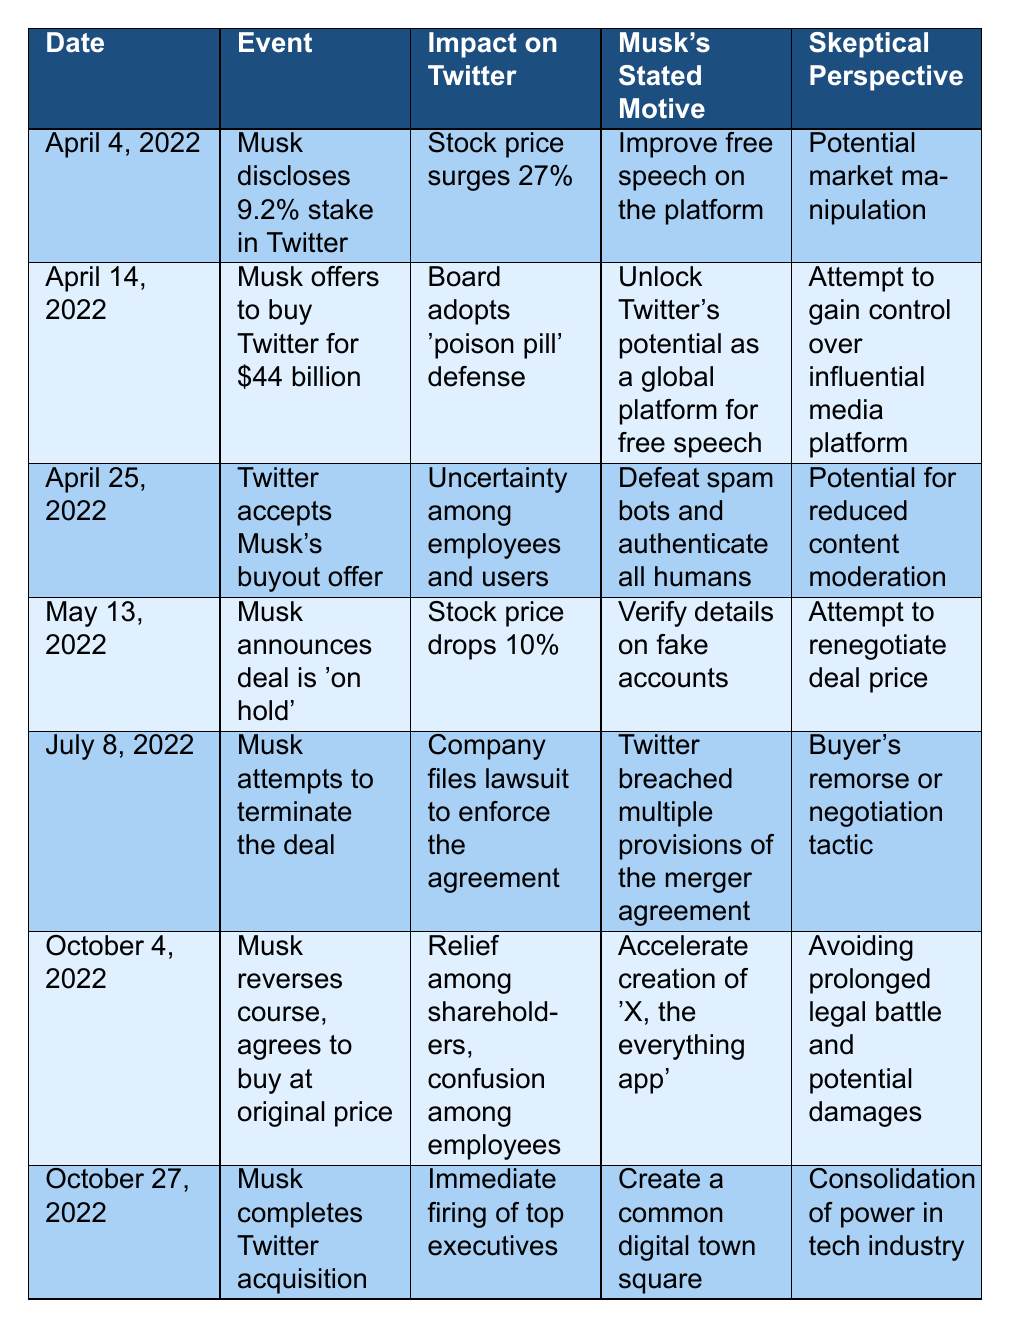What event happened on April 14, 2022? The table indicates that on April 14, 2022, Musk offered to buy Twitter for $44 billion.
Answer: Musk offers to buy Twitter for $44 billion What was the stock price change after Musk disclosed his stake on April 4, 2022? The table states that the stock price surged 27% after Musk disclosed his 9.2% stake in Twitter.
Answer: Stock price surged 27% Did Musk's motive change when he announced the deal was 'on hold' on May 13, 2022? Yes, Musk's stated motive changed to verifying details on fake accounts, which was different from his initial motivations concerning free speech.
Answer: Yes On which date did Musk complete the Twitter acquisition? According to the table, Musk completed the acquisition on October 27, 2022.
Answer: October 27, 2022 What was the impact on Twitter's stock price when Musk announced the deal was 'on hold'? The impact was a 10% drop in the stock price when Musk announced the deal was 'on hold'.
Answer: Stock price dropped 10% Was there immediate relief among shareholders when Musk reversed his decision on October 4, 2022? Yes, the table indicates there was relief among shareholders when Musk reversed his course and agreed to buy at the original price.
Answer: Yes What were the consequences for Twitter's executives after Musk completed the acquisition? The table shows that there was an immediate firing of top executives following the completion of the acquisition.
Answer: Immediate firing of top executives What was the common theme of Musk's stated motives regarding the acquisition? Musk's stated motives revolve around improving free speech and managing spam accounts, suggesting a focus on enhancing user experience.
Answer: Improving free speech and managing spam accounts How did the board of Twitter respond to Musk's buyout offer? The board adopted a 'poison pill' defense in response to Musk's $44 billion buyout offer.
Answer: Adopted 'poison pill' defense Compare the impact of Musk's disclosure of his stake and the acceptance of his buyout offer. His disclosure led to a 27% stock price surge, while the acceptance of the buyout offer created uncertainty among employees and users.
Answer: Stock price reaction and uncertainty created 